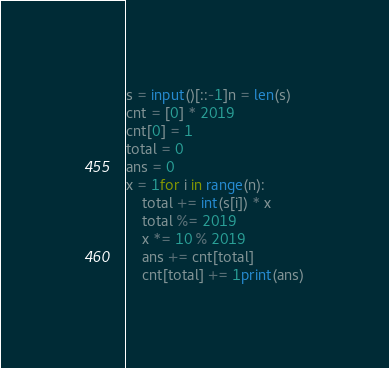<code> <loc_0><loc_0><loc_500><loc_500><_Python_>s = input()[::-1]n = len(s)
cnt = [0] * 2019
cnt[0] = 1
total = 0
ans = 0
x = 1for i in range(n):
    total += int(s[i]) * x
    total %= 2019
    x *= 10 % 2019
    ans += cnt[total]
    cnt[total] += 1print(ans)</code> 